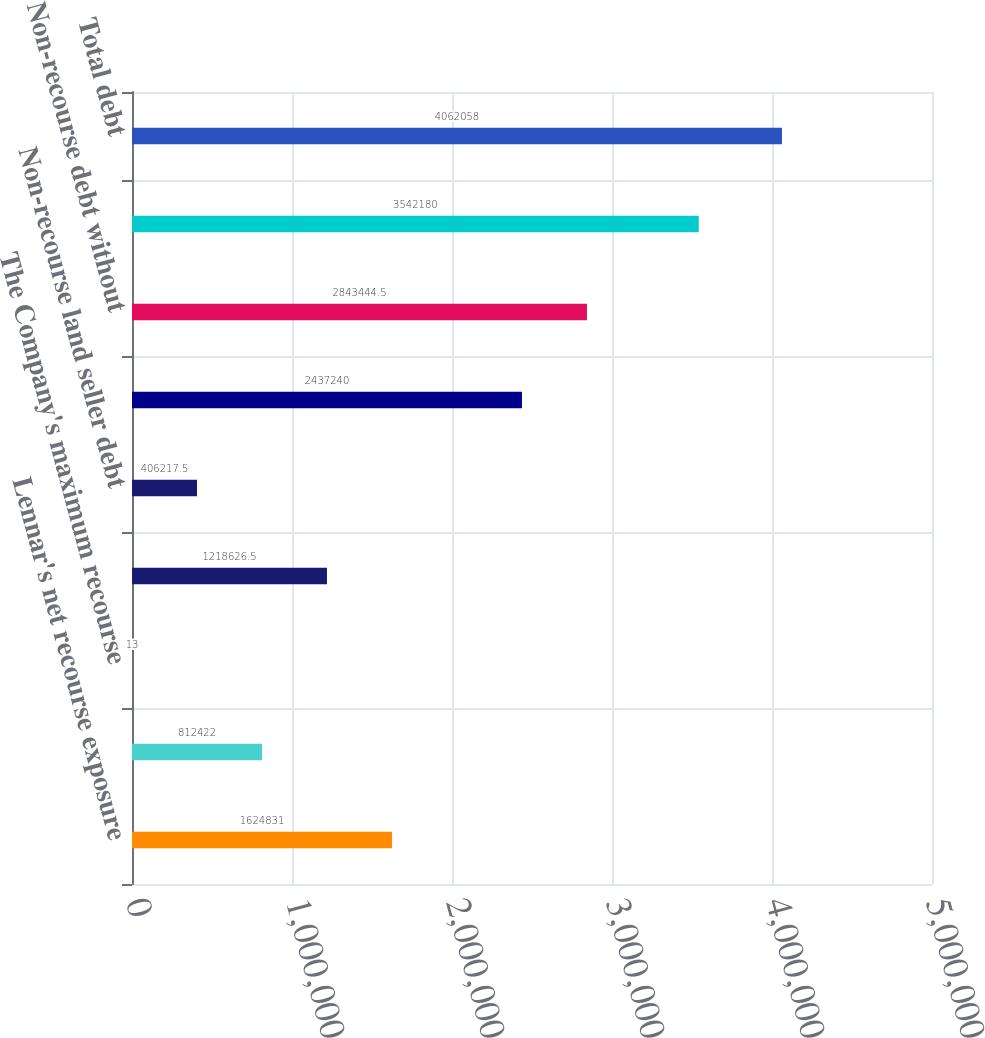<chart> <loc_0><loc_0><loc_500><loc_500><bar_chart><fcel>Lennar's net recourse exposure<fcel>Reimbursement agreements from<fcel>The Company's maximum recourse<fcel>Non-recourse bank debt and<fcel>Non-recourse land seller debt<fcel>Non-recourse debt with<fcel>Non-recourse debt without<fcel>Non-recourse debt to the<fcel>Total debt<nl><fcel>1.62483e+06<fcel>812422<fcel>13<fcel>1.21863e+06<fcel>406218<fcel>2.43724e+06<fcel>2.84344e+06<fcel>3.54218e+06<fcel>4.06206e+06<nl></chart> 